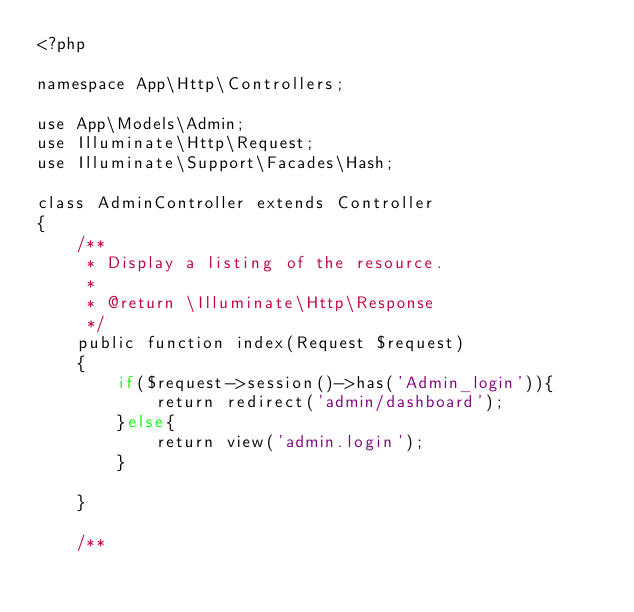<code> <loc_0><loc_0><loc_500><loc_500><_PHP_><?php

namespace App\Http\Controllers;

use App\Models\Admin;
use Illuminate\Http\Request;
use Illuminate\Support\Facades\Hash;

class AdminController extends Controller
{
    /**
     * Display a listing of the resource.
     *
     * @return \Illuminate\Http\Response
     */
    public function index(Request $request)
    {
        if($request->session()->has('Admin_login')){
            return redirect('admin/dashboard');
        }else{
            return view('admin.login');
        }
        
    }

    /**</code> 